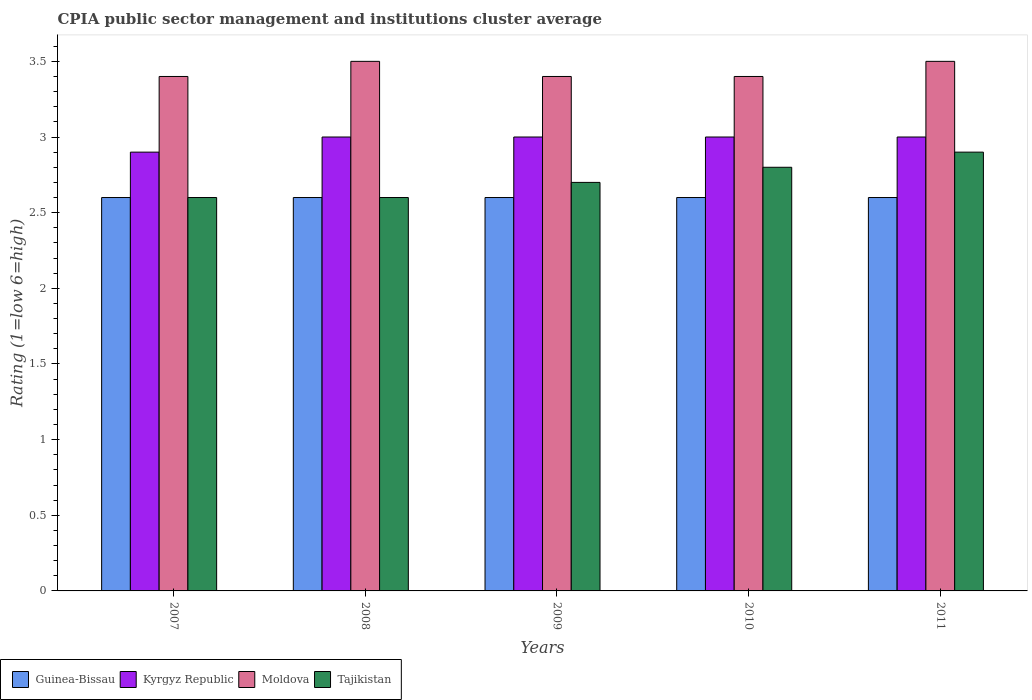Are the number of bars per tick equal to the number of legend labels?
Ensure brevity in your answer.  Yes. How many bars are there on the 3rd tick from the left?
Your response must be concise. 4. What is the CPIA rating in Tajikistan in 2009?
Keep it short and to the point. 2.7. Across all years, what is the minimum CPIA rating in Guinea-Bissau?
Make the answer very short. 2.6. In which year was the CPIA rating in Moldova minimum?
Your response must be concise. 2007. In the year 2011, what is the difference between the CPIA rating in Kyrgyz Republic and CPIA rating in Tajikistan?
Your answer should be compact. 0.1. In how many years, is the CPIA rating in Moldova greater than 1.6?
Your answer should be compact. 5. What is the ratio of the CPIA rating in Kyrgyz Republic in 2007 to that in 2008?
Ensure brevity in your answer.  0.97. Is the CPIA rating in Tajikistan in 2007 less than that in 2010?
Ensure brevity in your answer.  Yes. What is the difference between the highest and the second highest CPIA rating in Moldova?
Provide a short and direct response. 0. What is the difference between the highest and the lowest CPIA rating in Kyrgyz Republic?
Provide a succinct answer. 0.1. In how many years, is the CPIA rating in Moldova greater than the average CPIA rating in Moldova taken over all years?
Provide a succinct answer. 2. Is the sum of the CPIA rating in Kyrgyz Republic in 2007 and 2008 greater than the maximum CPIA rating in Moldova across all years?
Give a very brief answer. Yes. Is it the case that in every year, the sum of the CPIA rating in Moldova and CPIA rating in Kyrgyz Republic is greater than the sum of CPIA rating in Tajikistan and CPIA rating in Guinea-Bissau?
Provide a succinct answer. Yes. What does the 2nd bar from the left in 2011 represents?
Ensure brevity in your answer.  Kyrgyz Republic. What does the 2nd bar from the right in 2010 represents?
Give a very brief answer. Moldova. How many bars are there?
Provide a short and direct response. 20. Does the graph contain any zero values?
Offer a terse response. No. Where does the legend appear in the graph?
Offer a very short reply. Bottom left. How many legend labels are there?
Provide a short and direct response. 4. What is the title of the graph?
Give a very brief answer. CPIA public sector management and institutions cluster average. What is the label or title of the X-axis?
Provide a succinct answer. Years. What is the Rating (1=low 6=high) in Guinea-Bissau in 2007?
Your response must be concise. 2.6. What is the Rating (1=low 6=high) in Moldova in 2007?
Provide a short and direct response. 3.4. What is the Rating (1=low 6=high) of Tajikistan in 2007?
Offer a very short reply. 2.6. What is the Rating (1=low 6=high) in Kyrgyz Republic in 2008?
Your answer should be very brief. 3. What is the Rating (1=low 6=high) of Moldova in 2008?
Keep it short and to the point. 3.5. What is the Rating (1=low 6=high) in Guinea-Bissau in 2009?
Offer a very short reply. 2.6. What is the Rating (1=low 6=high) in Moldova in 2009?
Your answer should be very brief. 3.4. What is the Rating (1=low 6=high) of Tajikistan in 2009?
Make the answer very short. 2.7. What is the Rating (1=low 6=high) in Kyrgyz Republic in 2010?
Provide a short and direct response. 3. What is the Rating (1=low 6=high) in Guinea-Bissau in 2011?
Offer a terse response. 2.6. What is the Rating (1=low 6=high) in Moldova in 2011?
Offer a terse response. 3.5. What is the Rating (1=low 6=high) of Tajikistan in 2011?
Keep it short and to the point. 2.9. Across all years, what is the maximum Rating (1=low 6=high) of Guinea-Bissau?
Provide a succinct answer. 2.6. Across all years, what is the maximum Rating (1=low 6=high) of Tajikistan?
Provide a short and direct response. 2.9. Across all years, what is the minimum Rating (1=low 6=high) of Kyrgyz Republic?
Provide a short and direct response. 2.9. Across all years, what is the minimum Rating (1=low 6=high) of Moldova?
Your response must be concise. 3.4. What is the total Rating (1=low 6=high) in Kyrgyz Republic in the graph?
Offer a terse response. 14.9. What is the total Rating (1=low 6=high) in Moldova in the graph?
Ensure brevity in your answer.  17.2. What is the difference between the Rating (1=low 6=high) in Kyrgyz Republic in 2007 and that in 2009?
Make the answer very short. -0.1. What is the difference between the Rating (1=low 6=high) in Moldova in 2007 and that in 2009?
Your answer should be compact. 0. What is the difference between the Rating (1=low 6=high) of Tajikistan in 2007 and that in 2009?
Offer a very short reply. -0.1. What is the difference between the Rating (1=low 6=high) of Guinea-Bissau in 2007 and that in 2010?
Provide a succinct answer. 0. What is the difference between the Rating (1=low 6=high) of Moldova in 2007 and that in 2010?
Your answer should be compact. 0. What is the difference between the Rating (1=low 6=high) in Guinea-Bissau in 2007 and that in 2011?
Keep it short and to the point. 0. What is the difference between the Rating (1=low 6=high) of Kyrgyz Republic in 2007 and that in 2011?
Ensure brevity in your answer.  -0.1. What is the difference between the Rating (1=low 6=high) of Guinea-Bissau in 2008 and that in 2009?
Your answer should be compact. 0. What is the difference between the Rating (1=low 6=high) in Kyrgyz Republic in 2008 and that in 2009?
Provide a succinct answer. 0. What is the difference between the Rating (1=low 6=high) in Guinea-Bissau in 2008 and that in 2010?
Give a very brief answer. 0. What is the difference between the Rating (1=low 6=high) in Moldova in 2008 and that in 2010?
Offer a terse response. 0.1. What is the difference between the Rating (1=low 6=high) of Guinea-Bissau in 2008 and that in 2011?
Ensure brevity in your answer.  0. What is the difference between the Rating (1=low 6=high) in Guinea-Bissau in 2009 and that in 2010?
Your answer should be very brief. 0. What is the difference between the Rating (1=low 6=high) in Guinea-Bissau in 2009 and that in 2011?
Your answer should be compact. 0. What is the difference between the Rating (1=low 6=high) of Guinea-Bissau in 2010 and that in 2011?
Offer a terse response. 0. What is the difference between the Rating (1=low 6=high) in Moldova in 2010 and that in 2011?
Provide a succinct answer. -0.1. What is the difference between the Rating (1=low 6=high) in Tajikistan in 2010 and that in 2011?
Offer a very short reply. -0.1. What is the difference between the Rating (1=low 6=high) in Guinea-Bissau in 2007 and the Rating (1=low 6=high) in Kyrgyz Republic in 2008?
Your answer should be very brief. -0.4. What is the difference between the Rating (1=low 6=high) of Moldova in 2007 and the Rating (1=low 6=high) of Tajikistan in 2008?
Ensure brevity in your answer.  0.8. What is the difference between the Rating (1=low 6=high) in Guinea-Bissau in 2007 and the Rating (1=low 6=high) in Kyrgyz Republic in 2009?
Offer a terse response. -0.4. What is the difference between the Rating (1=low 6=high) in Guinea-Bissau in 2007 and the Rating (1=low 6=high) in Moldova in 2009?
Your answer should be compact. -0.8. What is the difference between the Rating (1=low 6=high) in Guinea-Bissau in 2007 and the Rating (1=low 6=high) in Tajikistan in 2009?
Your response must be concise. -0.1. What is the difference between the Rating (1=low 6=high) of Moldova in 2007 and the Rating (1=low 6=high) of Tajikistan in 2009?
Make the answer very short. 0.7. What is the difference between the Rating (1=low 6=high) in Guinea-Bissau in 2007 and the Rating (1=low 6=high) in Tajikistan in 2010?
Offer a terse response. -0.2. What is the difference between the Rating (1=low 6=high) in Guinea-Bissau in 2007 and the Rating (1=low 6=high) in Tajikistan in 2011?
Make the answer very short. -0.3. What is the difference between the Rating (1=low 6=high) in Moldova in 2007 and the Rating (1=low 6=high) in Tajikistan in 2011?
Make the answer very short. 0.5. What is the difference between the Rating (1=low 6=high) of Guinea-Bissau in 2008 and the Rating (1=low 6=high) of Kyrgyz Republic in 2009?
Make the answer very short. -0.4. What is the difference between the Rating (1=low 6=high) in Guinea-Bissau in 2008 and the Rating (1=low 6=high) in Moldova in 2009?
Your answer should be compact. -0.8. What is the difference between the Rating (1=low 6=high) of Guinea-Bissau in 2008 and the Rating (1=low 6=high) of Moldova in 2010?
Keep it short and to the point. -0.8. What is the difference between the Rating (1=low 6=high) in Kyrgyz Republic in 2008 and the Rating (1=low 6=high) in Moldova in 2010?
Make the answer very short. -0.4. What is the difference between the Rating (1=low 6=high) in Kyrgyz Republic in 2008 and the Rating (1=low 6=high) in Tajikistan in 2010?
Offer a very short reply. 0.2. What is the difference between the Rating (1=low 6=high) of Guinea-Bissau in 2008 and the Rating (1=low 6=high) of Kyrgyz Republic in 2011?
Keep it short and to the point. -0.4. What is the difference between the Rating (1=low 6=high) of Kyrgyz Republic in 2008 and the Rating (1=low 6=high) of Moldova in 2011?
Keep it short and to the point. -0.5. What is the difference between the Rating (1=low 6=high) of Moldova in 2008 and the Rating (1=low 6=high) of Tajikistan in 2011?
Give a very brief answer. 0.6. What is the difference between the Rating (1=low 6=high) of Kyrgyz Republic in 2009 and the Rating (1=low 6=high) of Tajikistan in 2010?
Provide a succinct answer. 0.2. What is the difference between the Rating (1=low 6=high) of Moldova in 2009 and the Rating (1=low 6=high) of Tajikistan in 2010?
Your answer should be very brief. 0.6. What is the difference between the Rating (1=low 6=high) of Kyrgyz Republic in 2009 and the Rating (1=low 6=high) of Moldova in 2011?
Provide a short and direct response. -0.5. What is the difference between the Rating (1=low 6=high) of Kyrgyz Republic in 2009 and the Rating (1=low 6=high) of Tajikistan in 2011?
Make the answer very short. 0.1. What is the difference between the Rating (1=low 6=high) in Moldova in 2009 and the Rating (1=low 6=high) in Tajikistan in 2011?
Provide a short and direct response. 0.5. What is the difference between the Rating (1=low 6=high) of Kyrgyz Republic in 2010 and the Rating (1=low 6=high) of Tajikistan in 2011?
Provide a short and direct response. 0.1. What is the difference between the Rating (1=low 6=high) of Moldova in 2010 and the Rating (1=low 6=high) of Tajikistan in 2011?
Give a very brief answer. 0.5. What is the average Rating (1=low 6=high) of Kyrgyz Republic per year?
Provide a short and direct response. 2.98. What is the average Rating (1=low 6=high) of Moldova per year?
Ensure brevity in your answer.  3.44. What is the average Rating (1=low 6=high) in Tajikistan per year?
Give a very brief answer. 2.72. In the year 2007, what is the difference between the Rating (1=low 6=high) in Guinea-Bissau and Rating (1=low 6=high) in Kyrgyz Republic?
Offer a very short reply. -0.3. In the year 2007, what is the difference between the Rating (1=low 6=high) in Guinea-Bissau and Rating (1=low 6=high) in Tajikistan?
Ensure brevity in your answer.  0. In the year 2007, what is the difference between the Rating (1=low 6=high) of Kyrgyz Republic and Rating (1=low 6=high) of Moldova?
Provide a succinct answer. -0.5. In the year 2007, what is the difference between the Rating (1=low 6=high) in Kyrgyz Republic and Rating (1=low 6=high) in Tajikistan?
Ensure brevity in your answer.  0.3. In the year 2008, what is the difference between the Rating (1=low 6=high) of Guinea-Bissau and Rating (1=low 6=high) of Kyrgyz Republic?
Offer a very short reply. -0.4. In the year 2008, what is the difference between the Rating (1=low 6=high) of Guinea-Bissau and Rating (1=low 6=high) of Moldova?
Keep it short and to the point. -0.9. In the year 2008, what is the difference between the Rating (1=low 6=high) of Moldova and Rating (1=low 6=high) of Tajikistan?
Give a very brief answer. 0.9. In the year 2009, what is the difference between the Rating (1=low 6=high) of Guinea-Bissau and Rating (1=low 6=high) of Moldova?
Your answer should be very brief. -0.8. In the year 2009, what is the difference between the Rating (1=low 6=high) in Guinea-Bissau and Rating (1=low 6=high) in Tajikistan?
Your response must be concise. -0.1. In the year 2010, what is the difference between the Rating (1=low 6=high) in Guinea-Bissau and Rating (1=low 6=high) in Moldova?
Make the answer very short. -0.8. In the year 2010, what is the difference between the Rating (1=low 6=high) in Guinea-Bissau and Rating (1=low 6=high) in Tajikistan?
Give a very brief answer. -0.2. In the year 2010, what is the difference between the Rating (1=low 6=high) in Kyrgyz Republic and Rating (1=low 6=high) in Moldova?
Give a very brief answer. -0.4. In the year 2010, what is the difference between the Rating (1=low 6=high) of Moldova and Rating (1=low 6=high) of Tajikistan?
Your response must be concise. 0.6. In the year 2011, what is the difference between the Rating (1=low 6=high) in Guinea-Bissau and Rating (1=low 6=high) in Tajikistan?
Provide a short and direct response. -0.3. In the year 2011, what is the difference between the Rating (1=low 6=high) in Kyrgyz Republic and Rating (1=low 6=high) in Moldova?
Offer a very short reply. -0.5. In the year 2011, what is the difference between the Rating (1=low 6=high) in Moldova and Rating (1=low 6=high) in Tajikistan?
Keep it short and to the point. 0.6. What is the ratio of the Rating (1=low 6=high) in Kyrgyz Republic in 2007 to that in 2008?
Provide a succinct answer. 0.97. What is the ratio of the Rating (1=low 6=high) of Moldova in 2007 to that in 2008?
Your response must be concise. 0.97. What is the ratio of the Rating (1=low 6=high) of Tajikistan in 2007 to that in 2008?
Keep it short and to the point. 1. What is the ratio of the Rating (1=low 6=high) in Guinea-Bissau in 2007 to that in 2009?
Your answer should be compact. 1. What is the ratio of the Rating (1=low 6=high) of Kyrgyz Republic in 2007 to that in 2009?
Make the answer very short. 0.97. What is the ratio of the Rating (1=low 6=high) in Kyrgyz Republic in 2007 to that in 2010?
Your answer should be compact. 0.97. What is the ratio of the Rating (1=low 6=high) in Kyrgyz Republic in 2007 to that in 2011?
Your answer should be very brief. 0.97. What is the ratio of the Rating (1=low 6=high) of Moldova in 2007 to that in 2011?
Make the answer very short. 0.97. What is the ratio of the Rating (1=low 6=high) of Tajikistan in 2007 to that in 2011?
Offer a very short reply. 0.9. What is the ratio of the Rating (1=low 6=high) of Guinea-Bissau in 2008 to that in 2009?
Give a very brief answer. 1. What is the ratio of the Rating (1=low 6=high) in Kyrgyz Republic in 2008 to that in 2009?
Offer a terse response. 1. What is the ratio of the Rating (1=low 6=high) in Moldova in 2008 to that in 2009?
Your answer should be compact. 1.03. What is the ratio of the Rating (1=low 6=high) of Guinea-Bissau in 2008 to that in 2010?
Give a very brief answer. 1. What is the ratio of the Rating (1=low 6=high) in Moldova in 2008 to that in 2010?
Provide a succinct answer. 1.03. What is the ratio of the Rating (1=low 6=high) of Tajikistan in 2008 to that in 2010?
Give a very brief answer. 0.93. What is the ratio of the Rating (1=low 6=high) in Guinea-Bissau in 2008 to that in 2011?
Make the answer very short. 1. What is the ratio of the Rating (1=low 6=high) of Kyrgyz Republic in 2008 to that in 2011?
Your response must be concise. 1. What is the ratio of the Rating (1=low 6=high) of Moldova in 2008 to that in 2011?
Give a very brief answer. 1. What is the ratio of the Rating (1=low 6=high) of Tajikistan in 2008 to that in 2011?
Make the answer very short. 0.9. What is the ratio of the Rating (1=low 6=high) in Kyrgyz Republic in 2009 to that in 2010?
Give a very brief answer. 1. What is the ratio of the Rating (1=low 6=high) in Moldova in 2009 to that in 2010?
Ensure brevity in your answer.  1. What is the ratio of the Rating (1=low 6=high) in Moldova in 2009 to that in 2011?
Offer a terse response. 0.97. What is the ratio of the Rating (1=low 6=high) in Tajikistan in 2009 to that in 2011?
Provide a short and direct response. 0.93. What is the ratio of the Rating (1=low 6=high) in Guinea-Bissau in 2010 to that in 2011?
Your answer should be very brief. 1. What is the ratio of the Rating (1=low 6=high) in Moldova in 2010 to that in 2011?
Keep it short and to the point. 0.97. What is the ratio of the Rating (1=low 6=high) of Tajikistan in 2010 to that in 2011?
Provide a short and direct response. 0.97. What is the difference between the highest and the second highest Rating (1=low 6=high) of Moldova?
Your answer should be very brief. 0. What is the difference between the highest and the second highest Rating (1=low 6=high) of Tajikistan?
Keep it short and to the point. 0.1. What is the difference between the highest and the lowest Rating (1=low 6=high) in Tajikistan?
Your answer should be very brief. 0.3. 